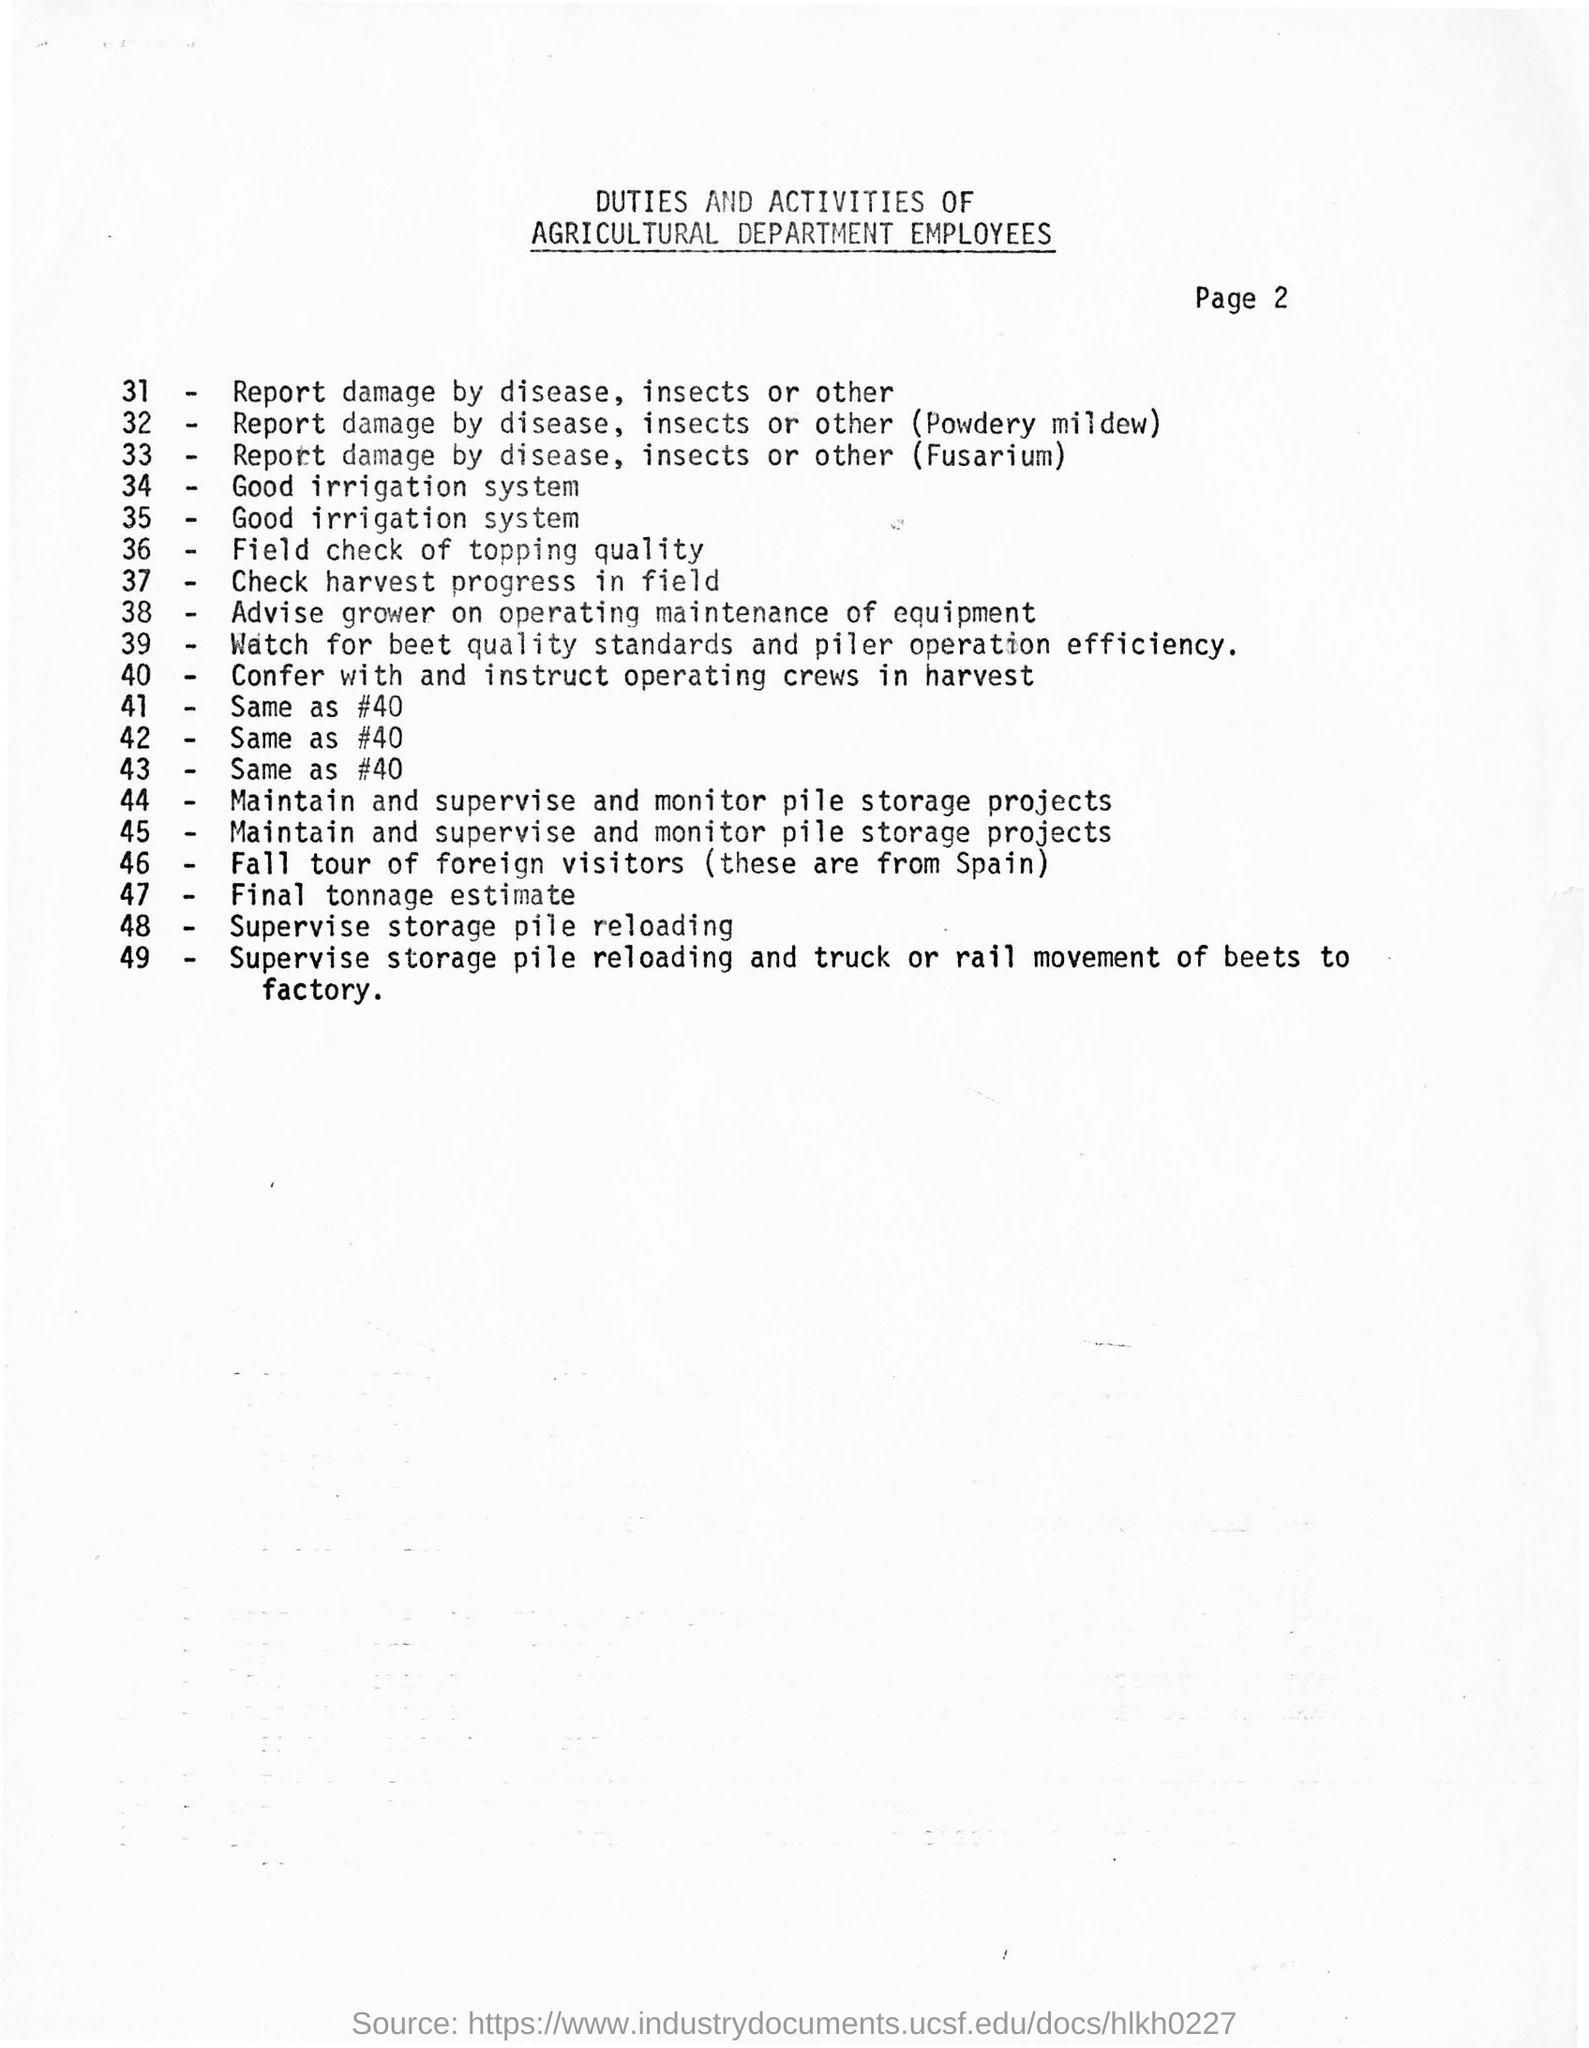Identify some key points in this picture. Foreign visitors originate from Spain. The page number mentioned is 2. The duties and activities of employees in the Agricultural department are mentioned. 